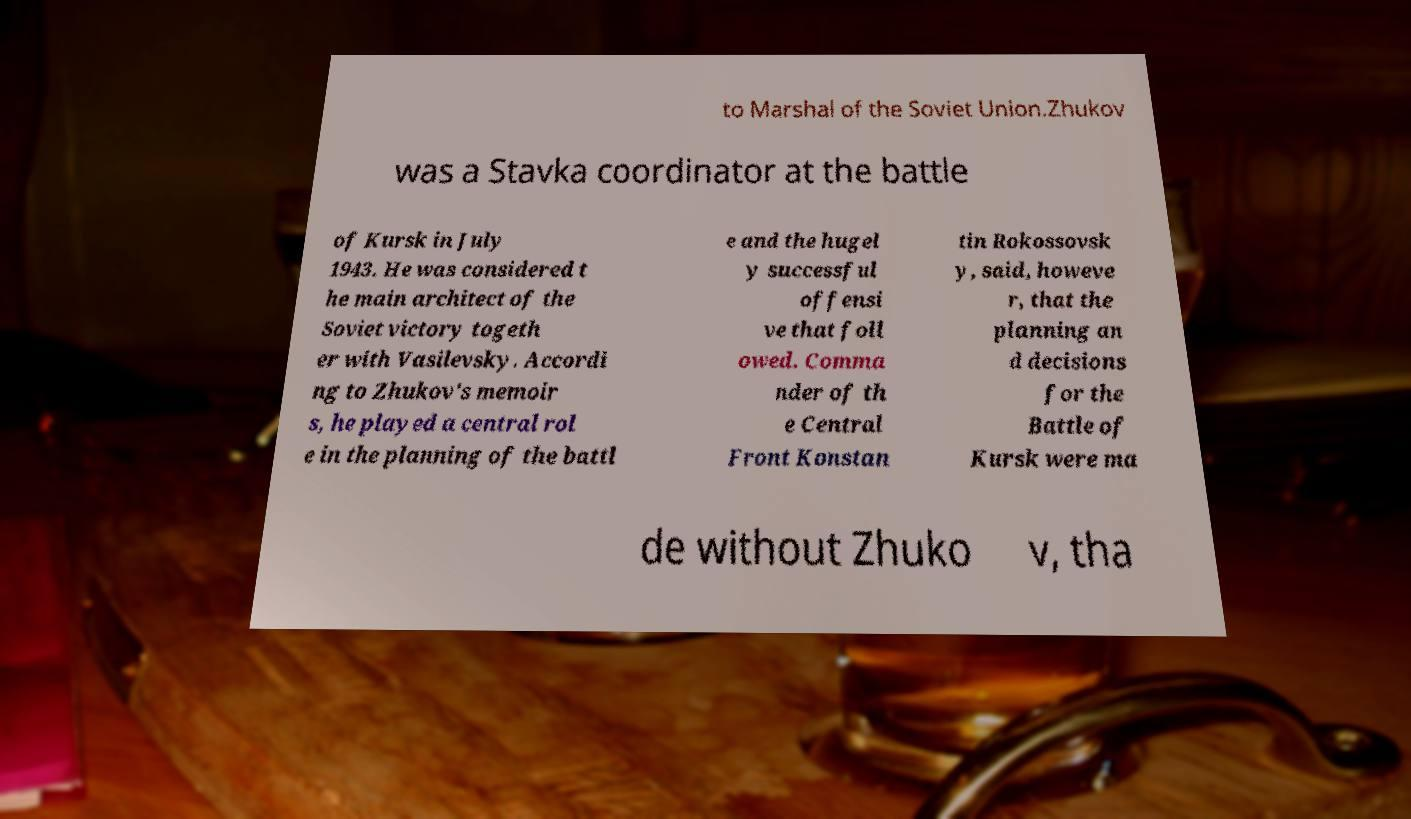Can you read and provide the text displayed in the image?This photo seems to have some interesting text. Can you extract and type it out for me? to Marshal of the Soviet Union.Zhukov was a Stavka coordinator at the battle of Kursk in July 1943. He was considered t he main architect of the Soviet victory togeth er with Vasilevsky. Accordi ng to Zhukov's memoir s, he played a central rol e in the planning of the battl e and the hugel y successful offensi ve that foll owed. Comma nder of th e Central Front Konstan tin Rokossovsk y, said, howeve r, that the planning an d decisions for the Battle of Kursk were ma de without Zhuko v, tha 